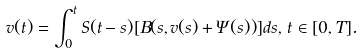<formula> <loc_0><loc_0><loc_500><loc_500>v ( t ) = \int _ { 0 } ^ { t } S ( t - s ) [ B ( s , v ( s ) + \Psi ( s ) ) ] d s , \, t \in [ 0 , T ] .</formula> 